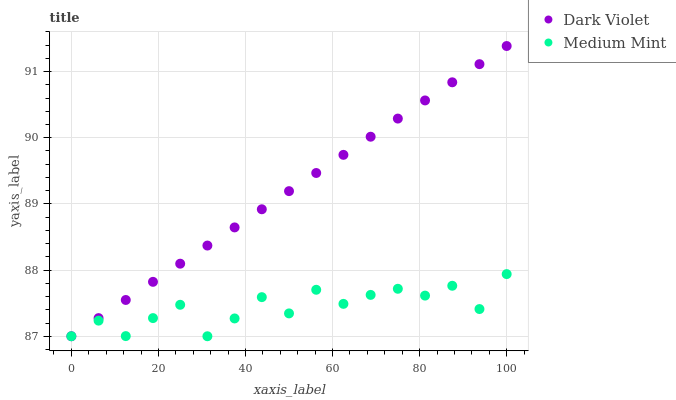Does Medium Mint have the minimum area under the curve?
Answer yes or no. Yes. Does Dark Violet have the maximum area under the curve?
Answer yes or no. Yes. Does Dark Violet have the minimum area under the curve?
Answer yes or no. No. Is Dark Violet the smoothest?
Answer yes or no. Yes. Is Medium Mint the roughest?
Answer yes or no. Yes. Is Dark Violet the roughest?
Answer yes or no. No. Does Medium Mint have the lowest value?
Answer yes or no. Yes. Does Dark Violet have the highest value?
Answer yes or no. Yes. Does Medium Mint intersect Dark Violet?
Answer yes or no. Yes. Is Medium Mint less than Dark Violet?
Answer yes or no. No. Is Medium Mint greater than Dark Violet?
Answer yes or no. No. 